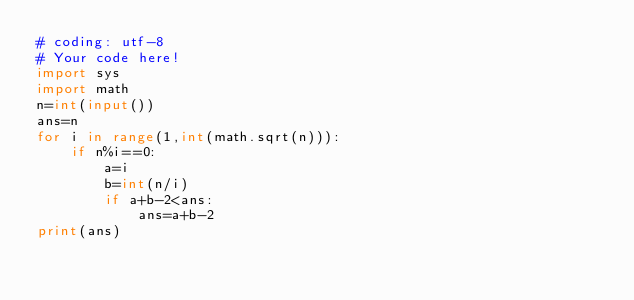<code> <loc_0><loc_0><loc_500><loc_500><_Python_># coding: utf-8
# Your code here!
import sys
import math
n=int(input())
ans=n
for i in range(1,int(math.sqrt(n))):
    if n%i==0:
        a=i
        b=int(n/i)
        if a+b-2<ans:
            ans=a+b-2
print(ans)
    
</code> 